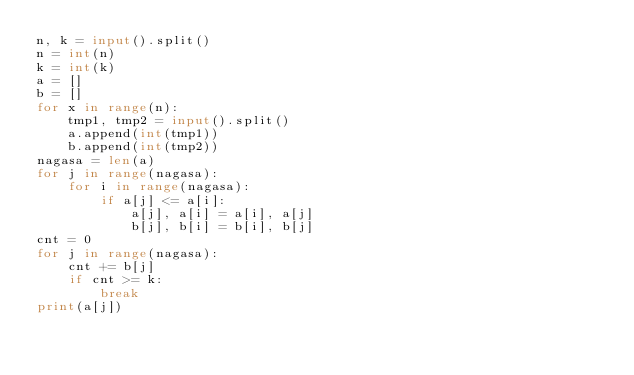<code> <loc_0><loc_0><loc_500><loc_500><_Python_>n, k = input().split()
n = int(n)
k = int(k)
a = []
b = []
for x in range(n):
    tmp1, tmp2 = input().split()
    a.append(int(tmp1))
    b.append(int(tmp2))
nagasa = len(a)
for j in range(nagasa):
    for i in range(nagasa):
        if a[j] <= a[i]:
            a[j], a[i] = a[i], a[j]
            b[j], b[i] = b[i], b[j]
cnt = 0
for j in range(nagasa):
    cnt += b[j]
    if cnt >= k:
        break
print(a[j])</code> 